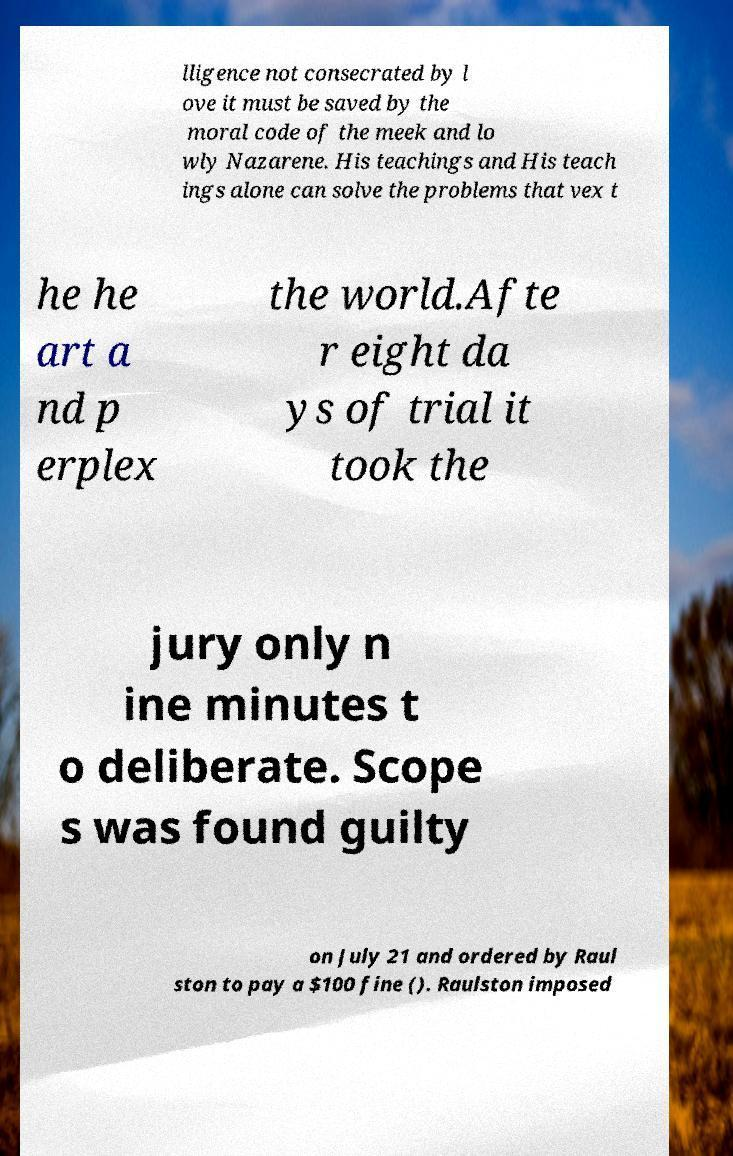Can you accurately transcribe the text from the provided image for me? lligence not consecrated by l ove it must be saved by the moral code of the meek and lo wly Nazarene. His teachings and His teach ings alone can solve the problems that vex t he he art a nd p erplex the world.Afte r eight da ys of trial it took the jury only n ine minutes t o deliberate. Scope s was found guilty on July 21 and ordered by Raul ston to pay a $100 fine (). Raulston imposed 